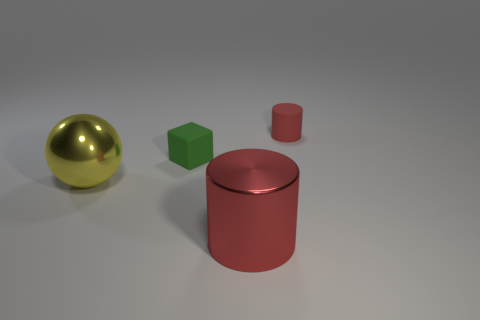Add 4 red metal cylinders. How many objects exist? 8 Subtract all cubes. How many objects are left? 3 Subtract 0 purple blocks. How many objects are left? 4 Subtract all tiny green things. Subtract all big yellow objects. How many objects are left? 2 Add 4 tiny matte objects. How many tiny matte objects are left? 6 Add 4 metal things. How many metal things exist? 6 